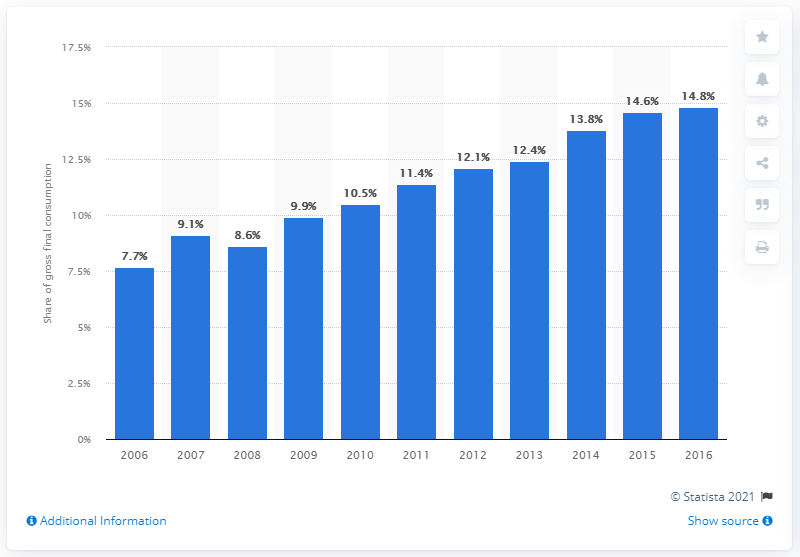Point out several critical features in this image. During the period of 2006 to 2016, the percentage of energy generated from renewable sources in Germany was 7.7%. 